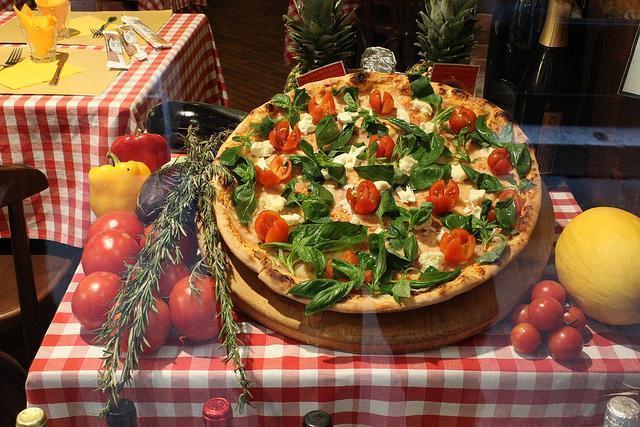How many chairs are in the picture?
Give a very brief answer. 2. How many dining tables can you see?
Give a very brief answer. 2. How many little girls can be seen?
Give a very brief answer. 0. 